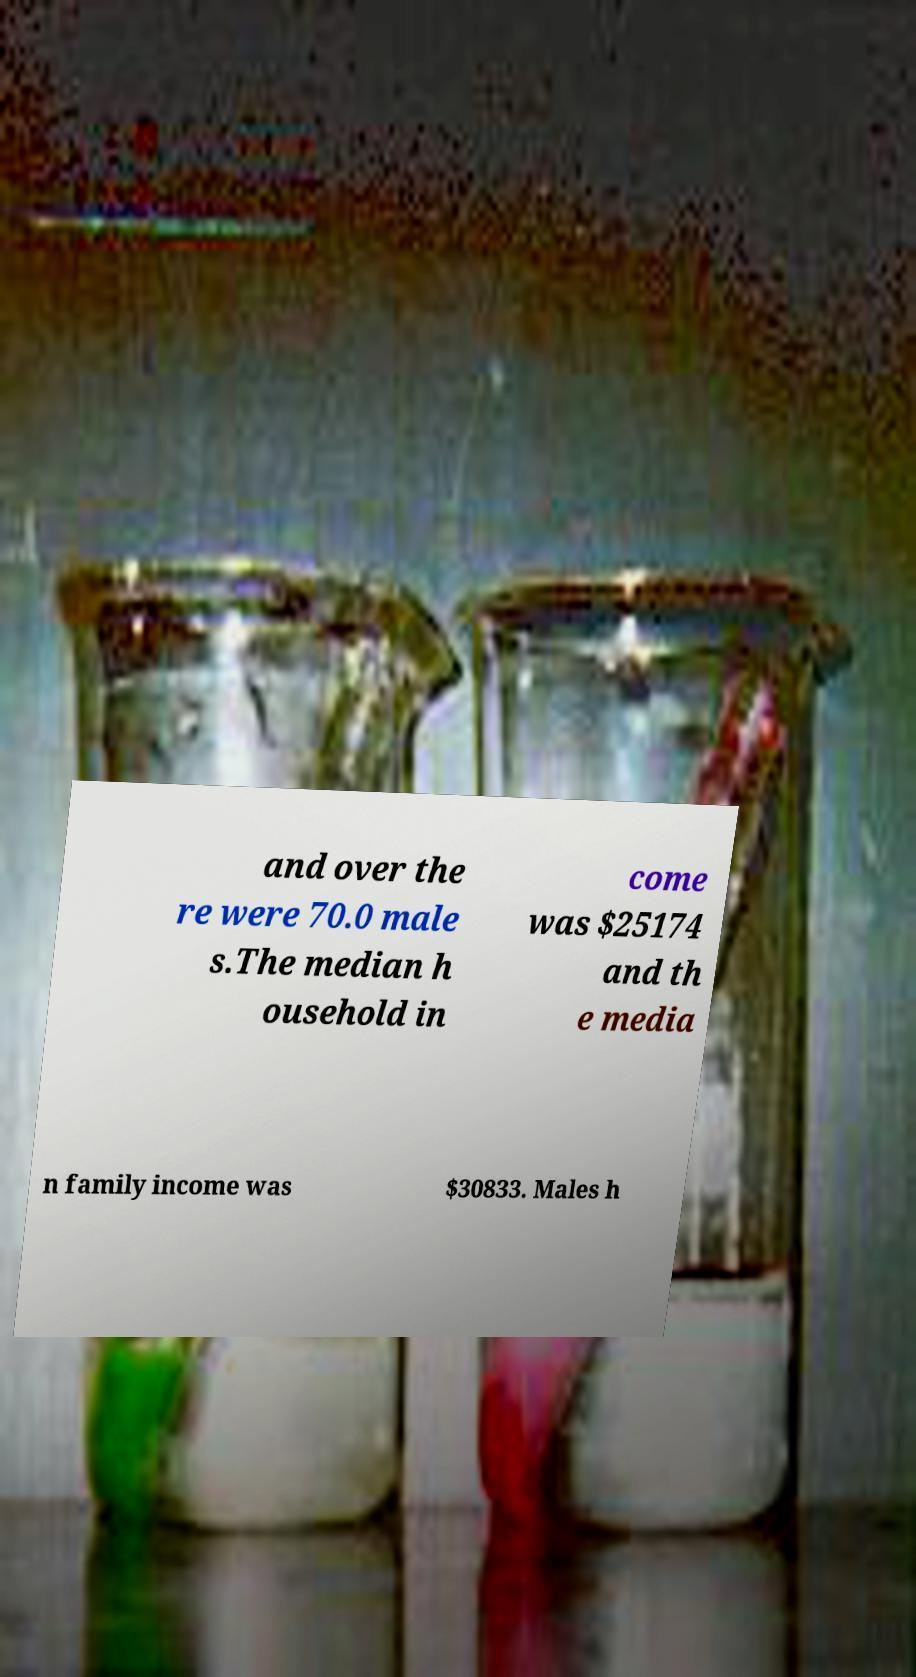What messages or text are displayed in this image? I need them in a readable, typed format. and over the re were 70.0 male s.The median h ousehold in come was $25174 and th e media n family income was $30833. Males h 